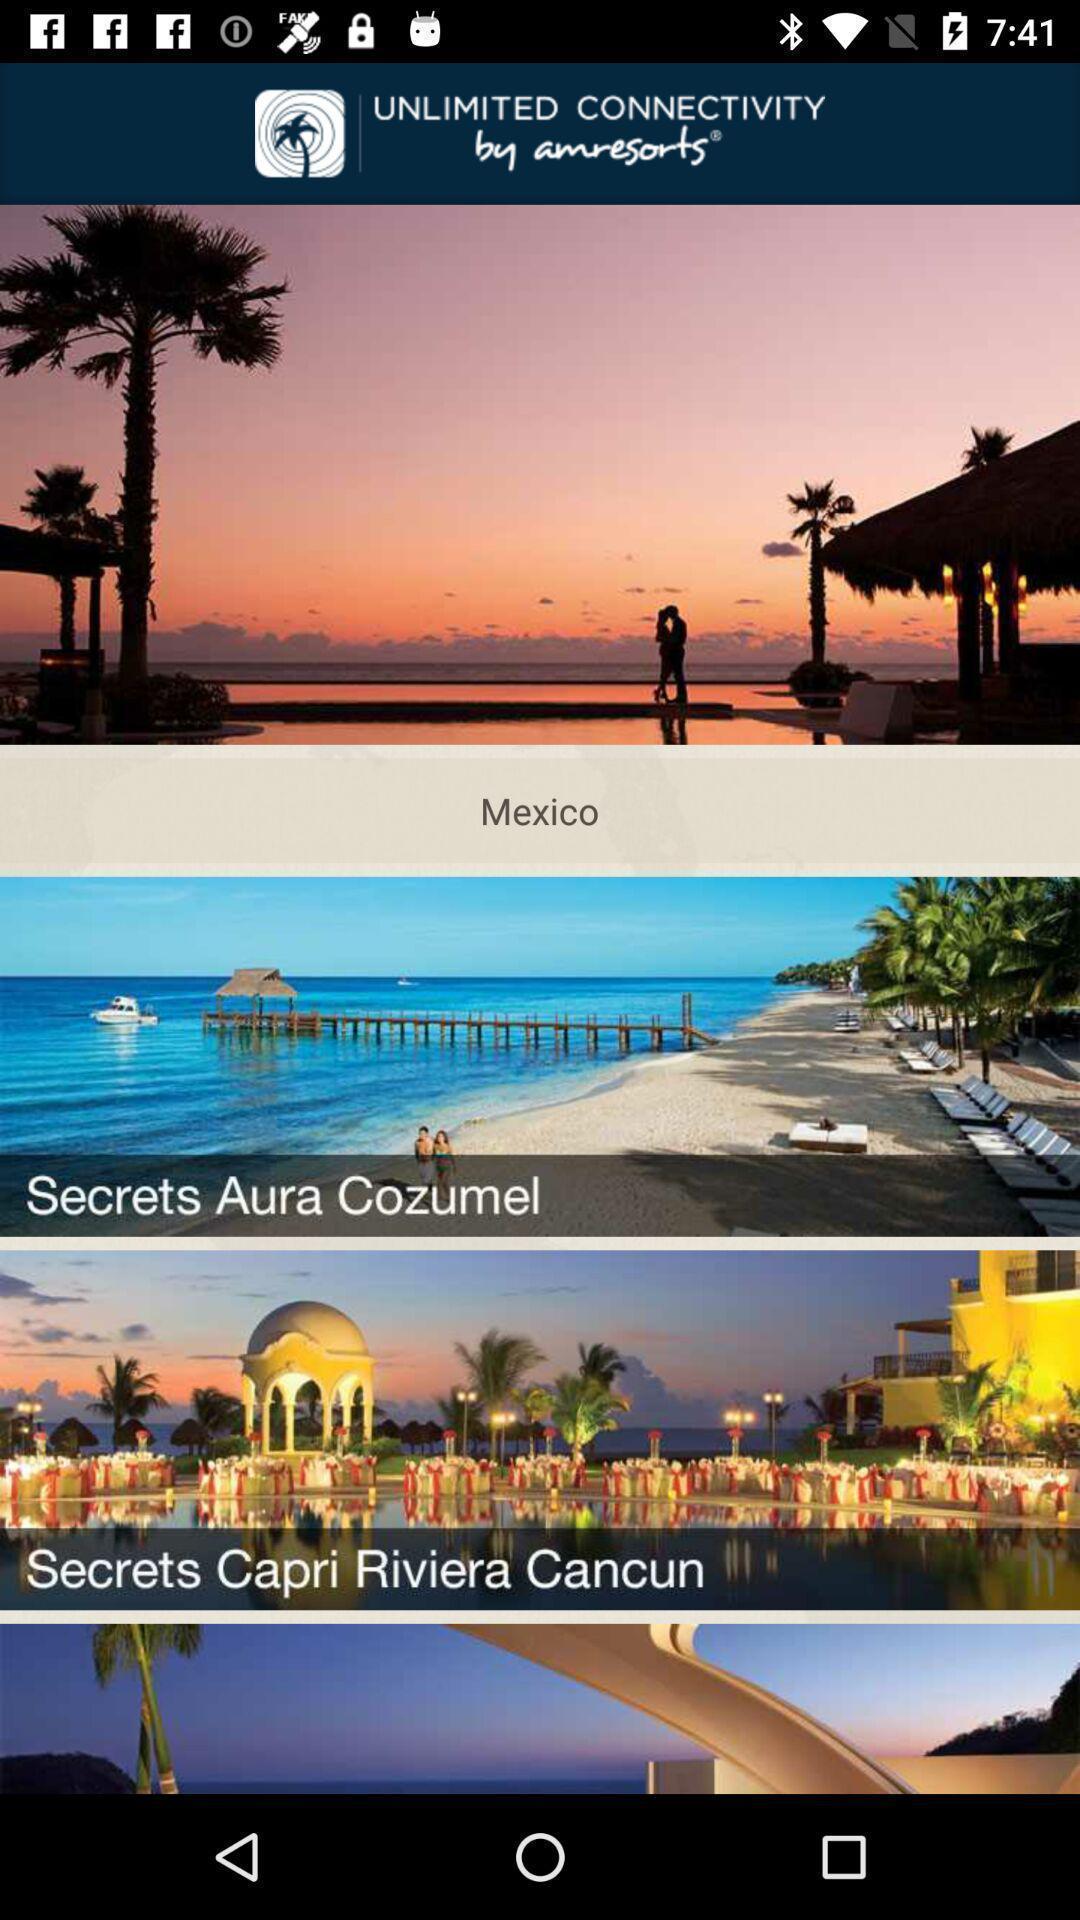Tell me about the visual elements in this screen capture. Page displaying various places in resorts app. 